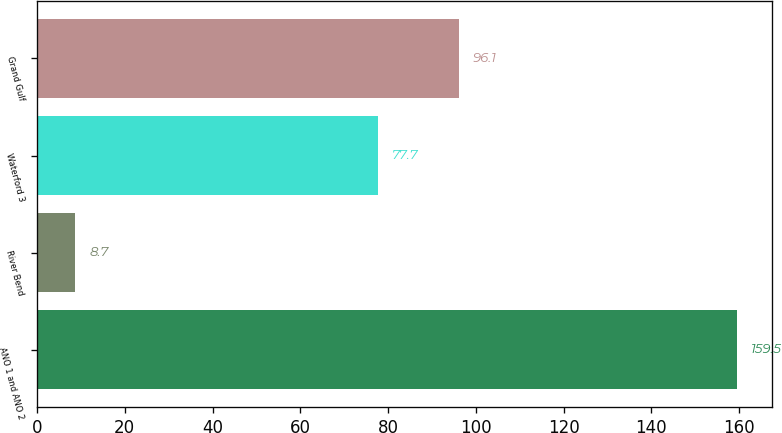<chart> <loc_0><loc_0><loc_500><loc_500><bar_chart><fcel>ANO 1 and ANO 2<fcel>River Bend<fcel>Waterford 3<fcel>Grand Gulf<nl><fcel>159.5<fcel>8.7<fcel>77.7<fcel>96.1<nl></chart> 